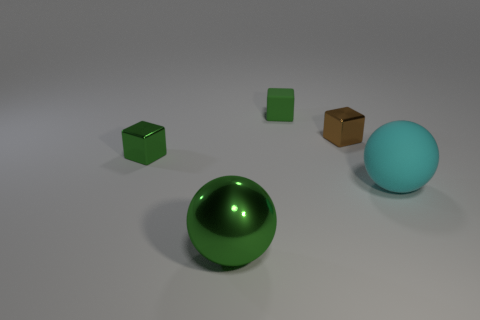Subtract all green rubber blocks. How many blocks are left? 2 Subtract 1 spheres. How many spheres are left? 1 Add 5 small yellow things. How many objects exist? 10 Subtract all brown blocks. How many blocks are left? 2 Subtract all spheres. How many objects are left? 3 Add 2 green blocks. How many green blocks exist? 4 Subtract 0 red balls. How many objects are left? 5 Subtract all green balls. Subtract all yellow blocks. How many balls are left? 1 Subtract all brown cylinders. How many blue balls are left? 0 Subtract all large yellow blocks. Subtract all small green shiny cubes. How many objects are left? 4 